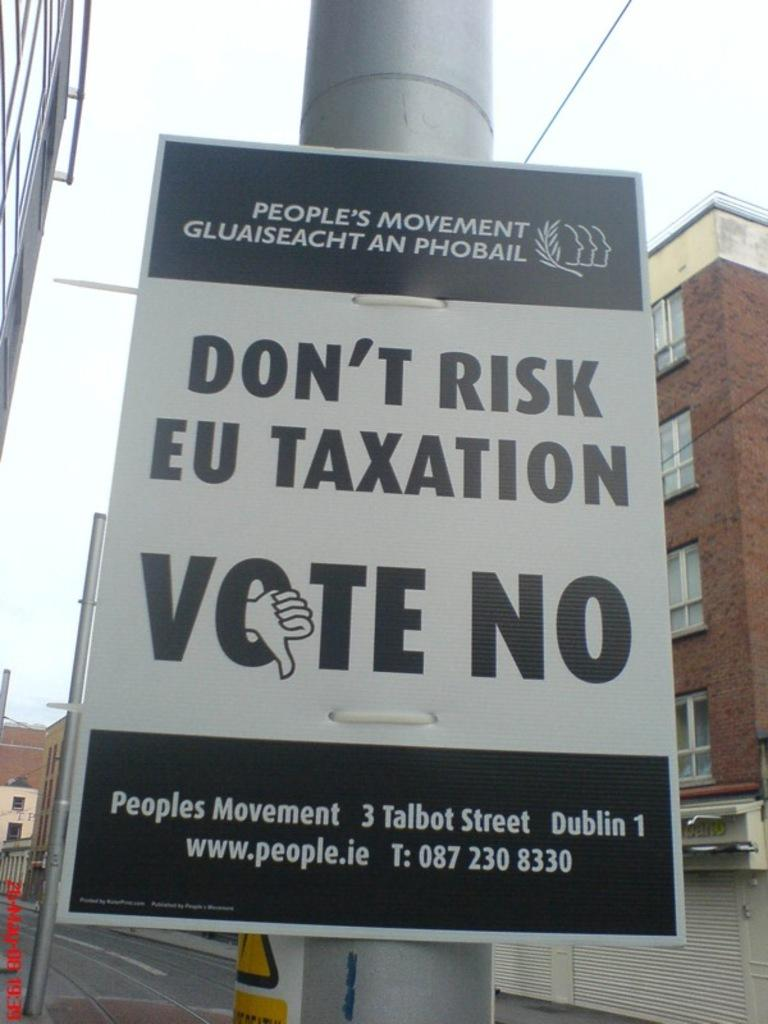<image>
Render a clear and concise summary of the photo. A sign says to vote no and is sponsored by the people's movement. 